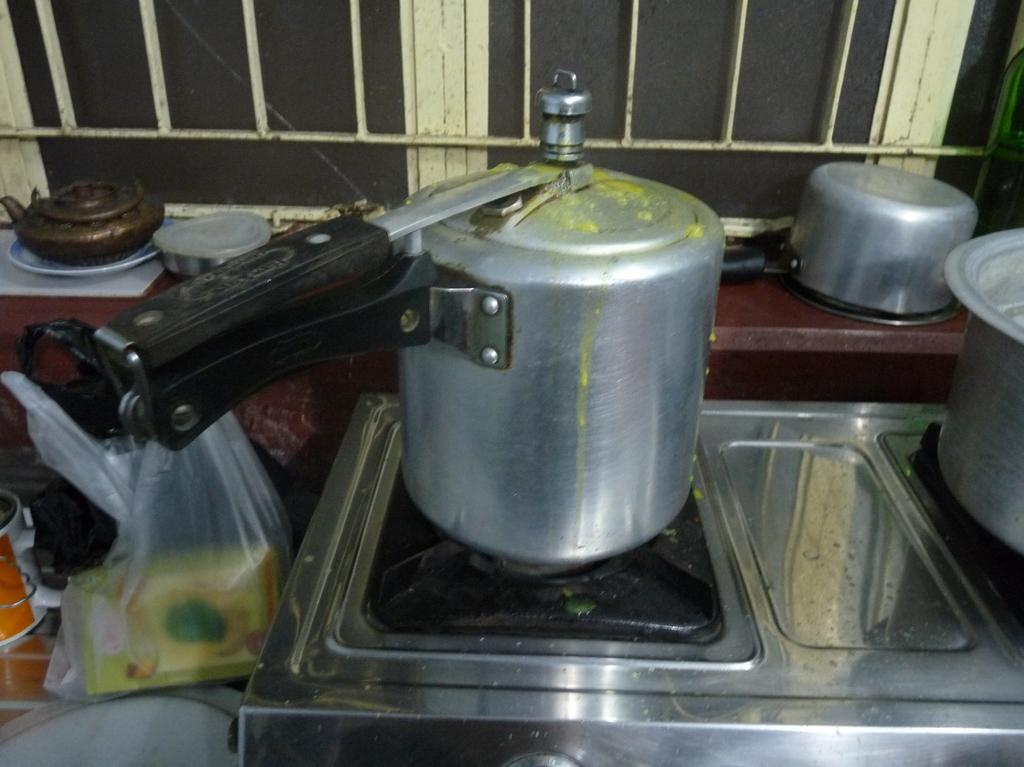What type of appliance is present in the image? There is a stove and a cooker in the image. What can be found on the stove or cooker? There are bowls on the stove or cooker. What is covering the bowls? There is a plastic cover in the image. Where are the stove, cooker, and bowls located? They are on a platform. What can be seen in the background of the image? There is a window in the background of the image. What statement does the stranger make about the stove in the image? There is no stranger present in the image, so no statement can be attributed to them regarding the stove. 